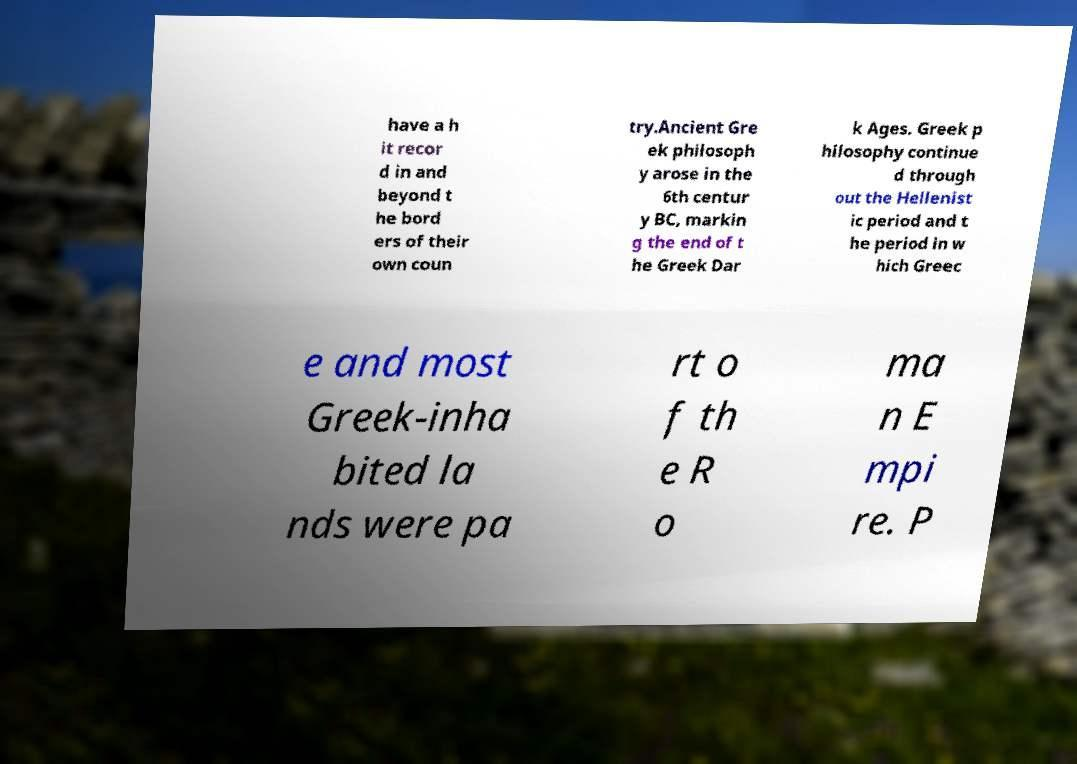What messages or text are displayed in this image? I need them in a readable, typed format. have a h it recor d in and beyond t he bord ers of their own coun try.Ancient Gre ek philosoph y arose in the 6th centur y BC, markin g the end of t he Greek Dar k Ages. Greek p hilosophy continue d through out the Hellenist ic period and t he period in w hich Greec e and most Greek-inha bited la nds were pa rt o f th e R o ma n E mpi re. P 